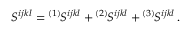<formula> <loc_0><loc_0><loc_500><loc_500>S ^ { i j k l } ^ { ( 1 ) } \, S ^ { i j k l } ^ { ( 2 ) } \, S ^ { i j k l } ^ { ( 3 ) } \, S ^ { i j k l } \, .</formula> 